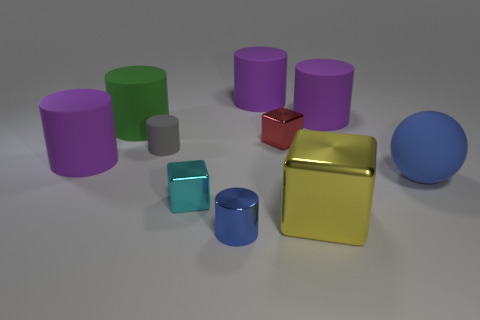Are there any large matte things of the same color as the metallic cylinder?
Keep it short and to the point. Yes. What number of tiny matte objects are there?
Your answer should be compact. 1. What is the material of the cylinder in front of the purple matte cylinder that is on the left side of the tiny cylinder that is in front of the large shiny block?
Ensure brevity in your answer.  Metal. Are there any blue cylinders that have the same material as the red thing?
Make the answer very short. Yes. Does the tiny red cube have the same material as the yellow object?
Your response must be concise. Yes. How many balls are purple rubber objects or big blue matte things?
Make the answer very short. 1. What is the color of the small cylinder that is the same material as the big ball?
Your answer should be very brief. Gray. Is the number of tiny cyan cylinders less than the number of blue cylinders?
Your response must be concise. Yes. Does the big purple object that is to the left of the cyan object have the same shape as the blue thing that is in front of the small cyan cube?
Offer a very short reply. Yes. How many things are brown metal cylinders or blue metal cylinders?
Your answer should be very brief. 1. 